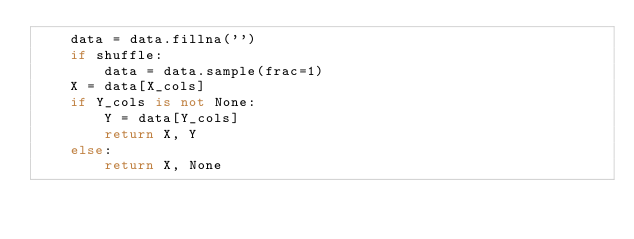Convert code to text. <code><loc_0><loc_0><loc_500><loc_500><_Python_>    data = data.fillna('')
    if shuffle:
        data = data.sample(frac=1)
    X = data[X_cols]
    if Y_cols is not None:
        Y = data[Y_cols]
        return X, Y
    else:
        return X, None

</code> 